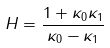Convert formula to latex. <formula><loc_0><loc_0><loc_500><loc_500>H = \frac { 1 + \kappa _ { 0 } \kappa _ { 1 } } { \kappa _ { 0 } - \kappa _ { 1 } }</formula> 